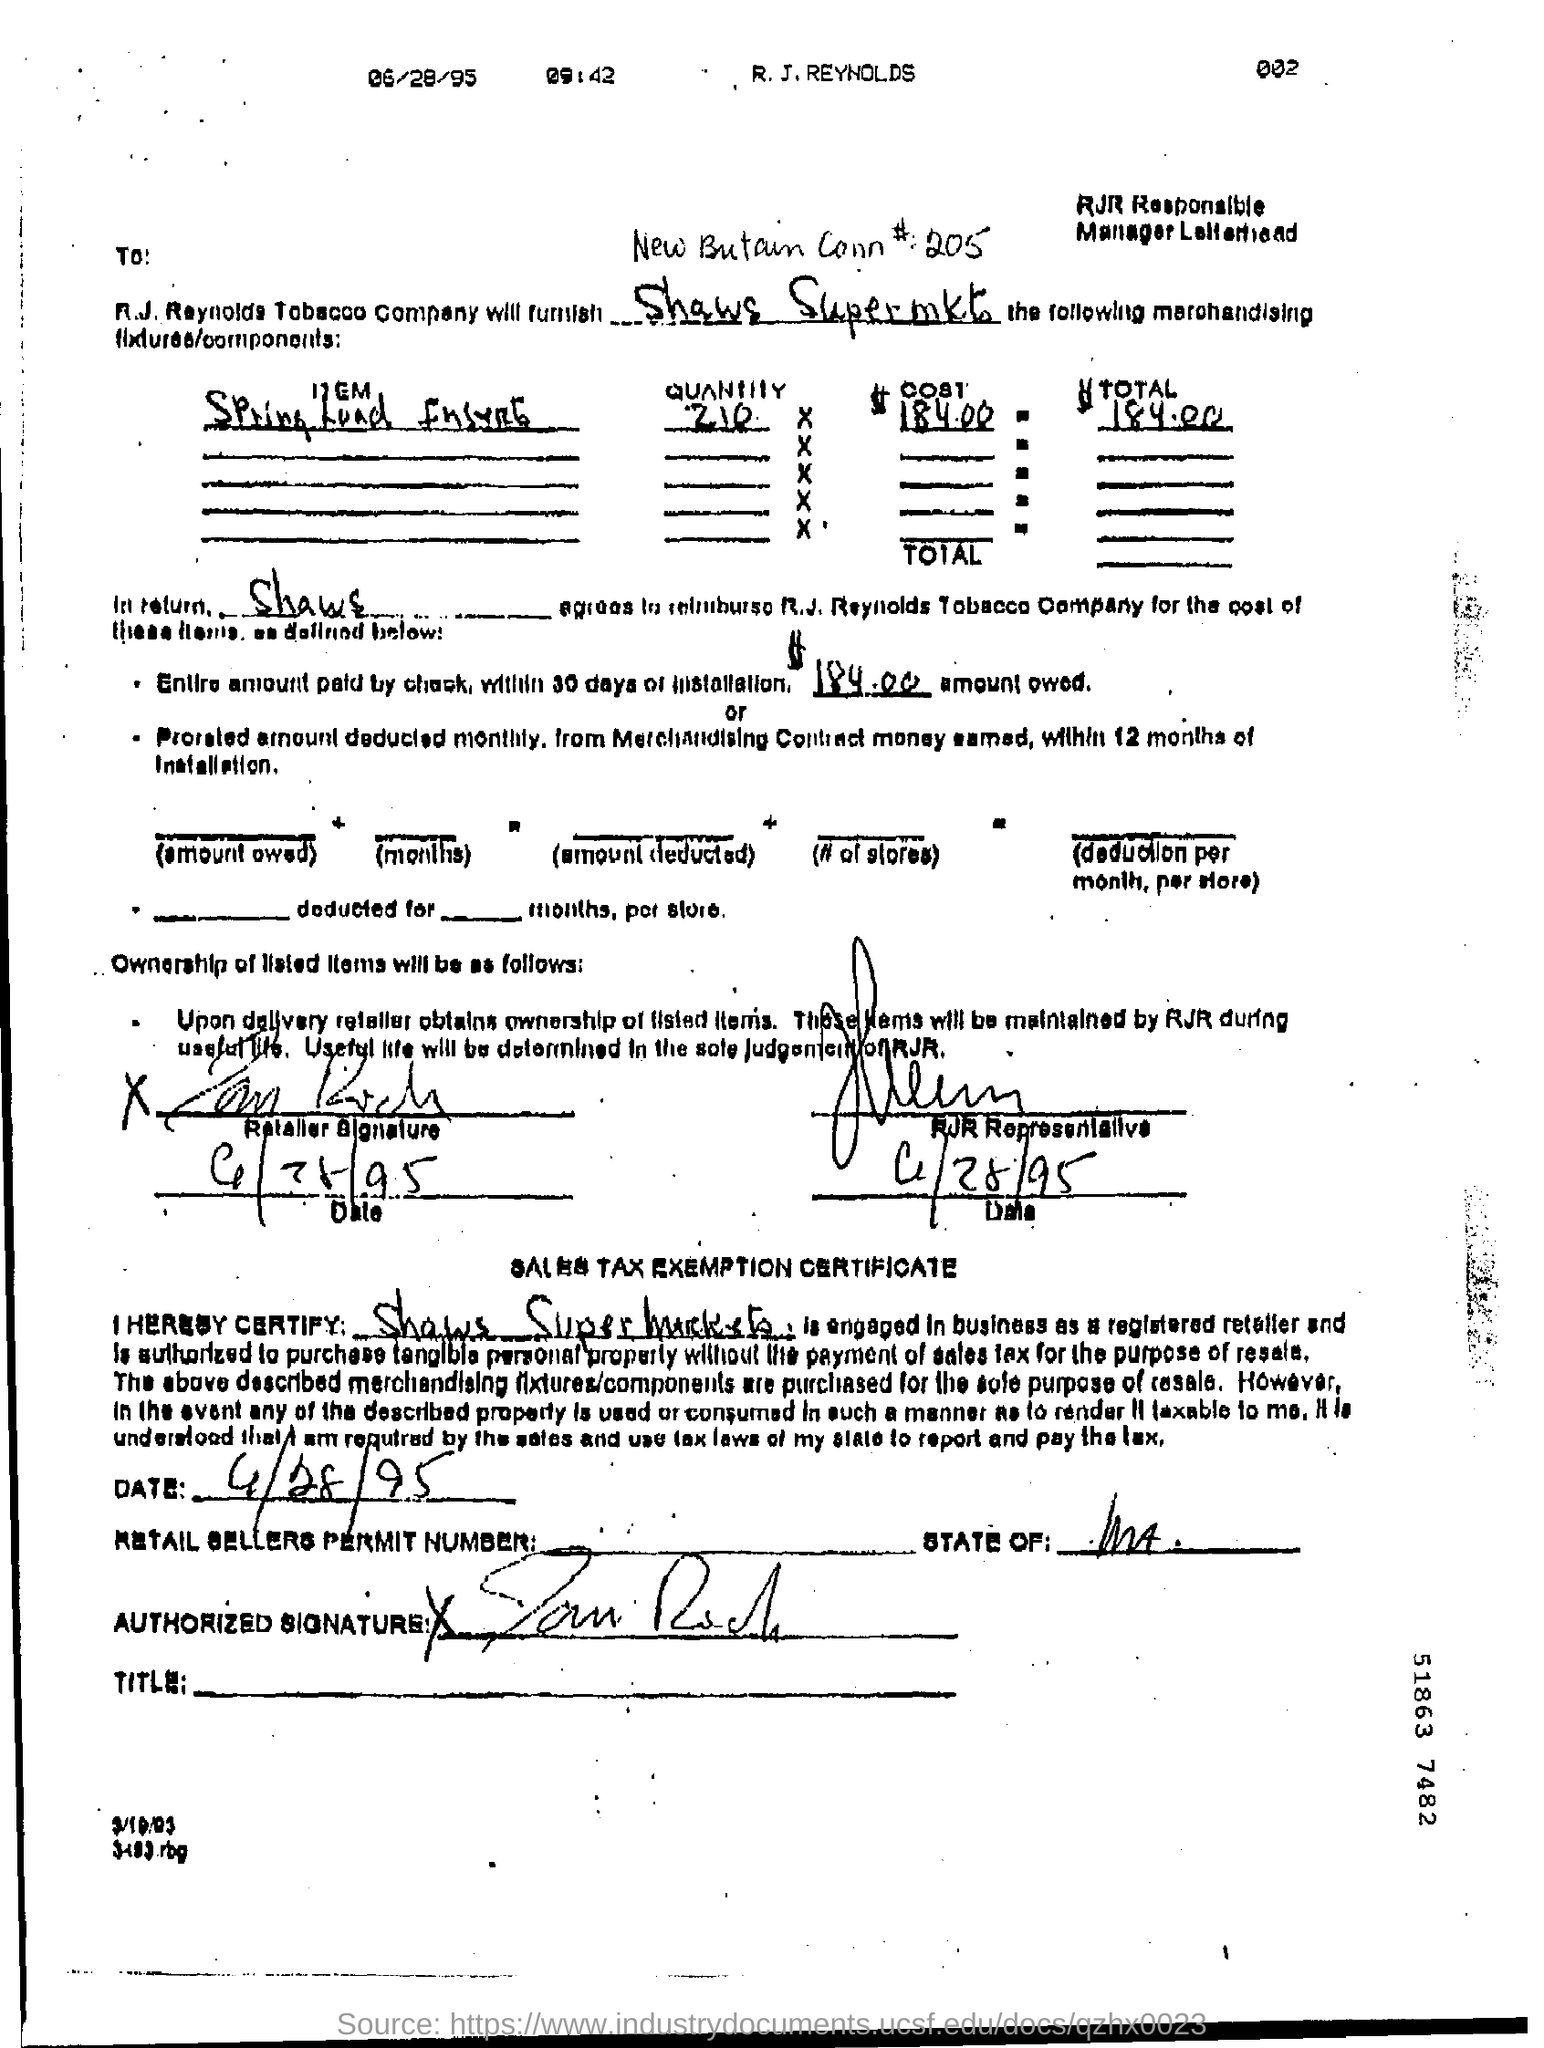Draw attention to some important aspects in this diagram. The date in the sales tax exemption certificate is 4/28/95. The document at the top of the page displays the date in small letters as 06/28/95. The time at the top of the document in small letters is 09:42. Under the "Sales tax exemption certificate," the name of the supermarket mentioned is "Shaws Supermarkets. The RJR Representative signed the document on June 28, 1995. 